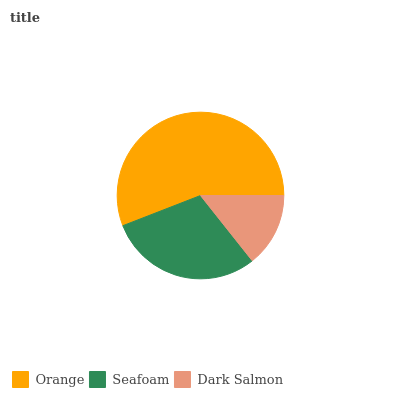Is Dark Salmon the minimum?
Answer yes or no. Yes. Is Orange the maximum?
Answer yes or no. Yes. Is Seafoam the minimum?
Answer yes or no. No. Is Seafoam the maximum?
Answer yes or no. No. Is Orange greater than Seafoam?
Answer yes or no. Yes. Is Seafoam less than Orange?
Answer yes or no. Yes. Is Seafoam greater than Orange?
Answer yes or no. No. Is Orange less than Seafoam?
Answer yes or no. No. Is Seafoam the high median?
Answer yes or no. Yes. Is Seafoam the low median?
Answer yes or no. Yes. Is Dark Salmon the high median?
Answer yes or no. No. Is Dark Salmon the low median?
Answer yes or no. No. 